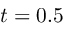<formula> <loc_0><loc_0><loc_500><loc_500>t = 0 . 5</formula> 